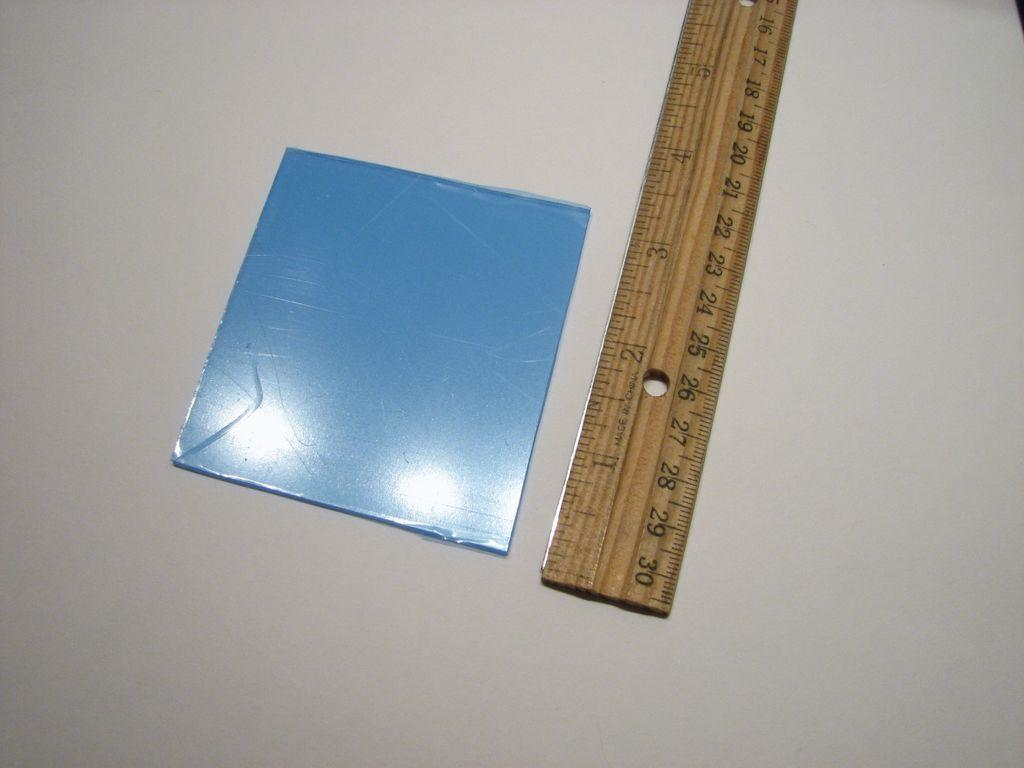<image>
Summarize the visual content of the image. A ruler measuring a small blue square showing that is a little over 3 inches large. 